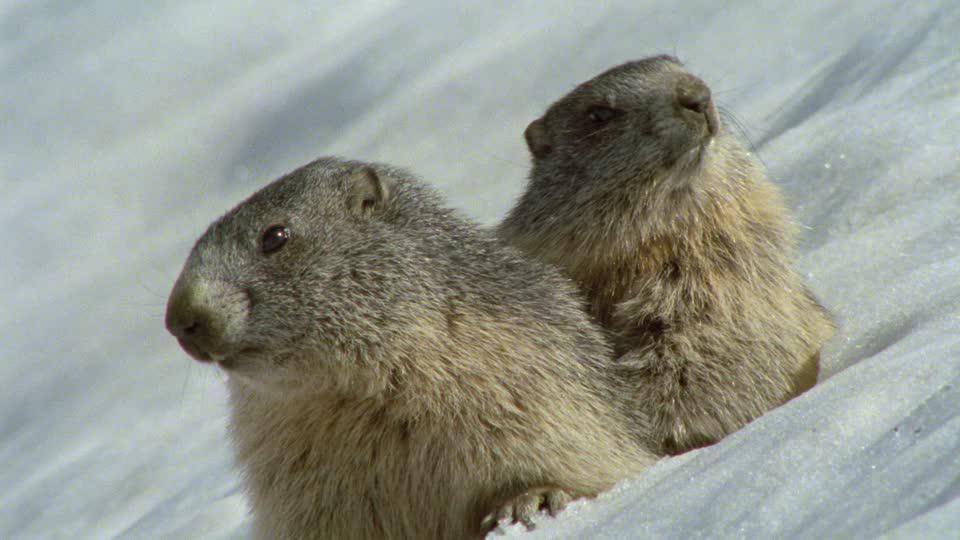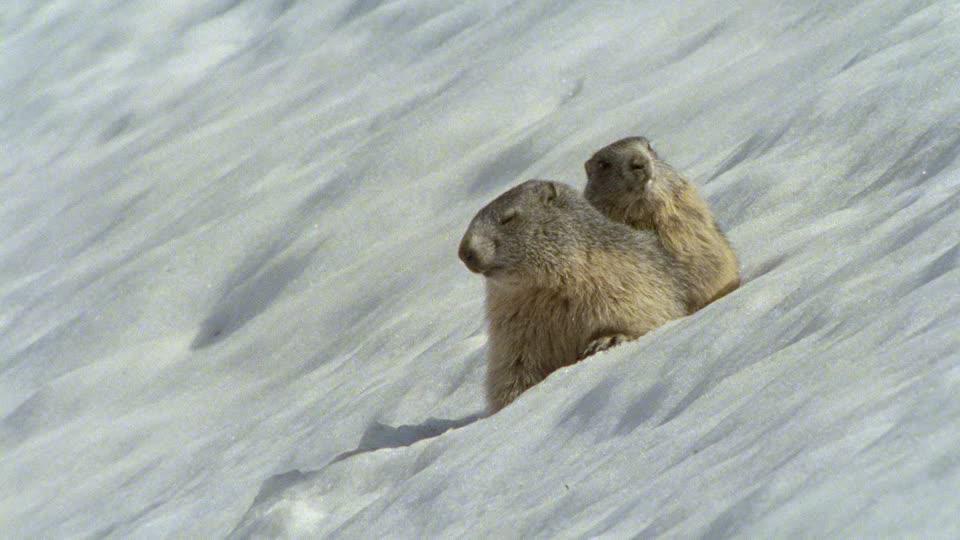The first image is the image on the left, the second image is the image on the right. Analyze the images presented: Is the assertion "One animal is in the snow in the image on the left." valid? Answer yes or no. No. The first image is the image on the left, the second image is the image on the right. Evaluate the accuracy of this statement regarding the images: "One image contains twice as many marmots as the other image.". Is it true? Answer yes or no. No. 